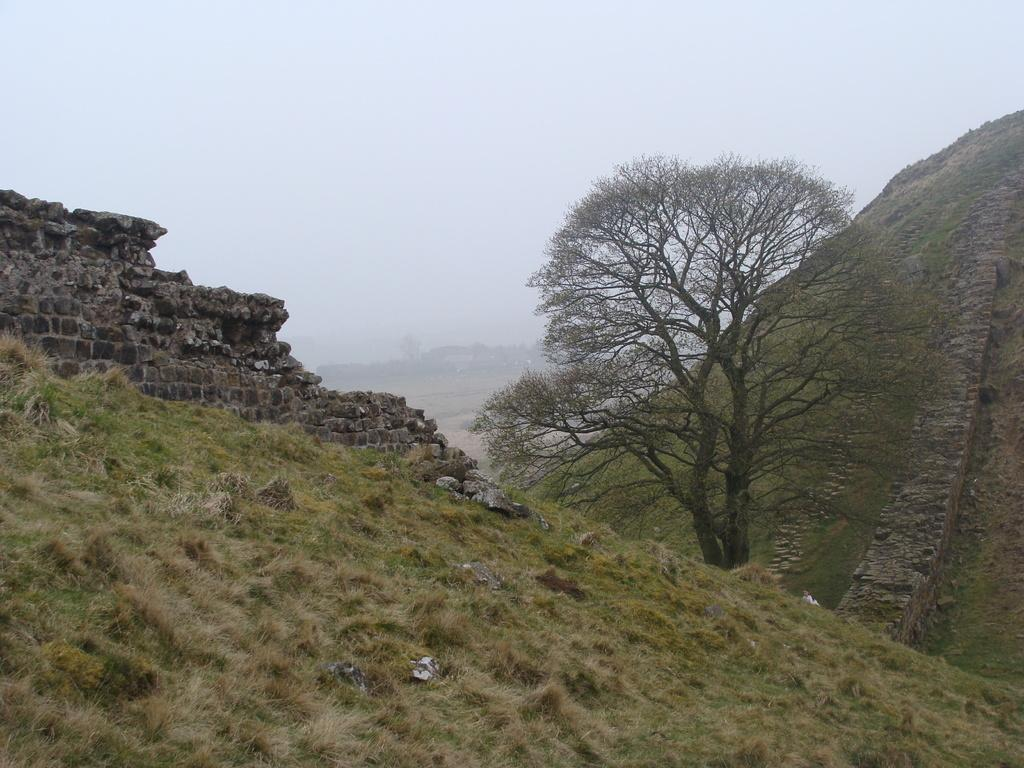What type of structure can be seen in the image? There is a wall in the image. What type of vegetation is present in the image? There is grass in the image. What type of plant is taller and more prominent in the image? There is a tree in the image. What type of natural formation can be seen in the distance? There are mountains in the image. What part of the natural environment is visible in the image? The sky is visible in the image. What is the level of anger expressed by the tree in the image? There is no indication of anger in the image, as it is a depiction of a tree and not a living being capable of expressing emotions. What is the position of the grass in relation to the wall in the image? The grass is not in a specific position relative to the wall, as it is a natural feature that can be found in various locations within the image. 